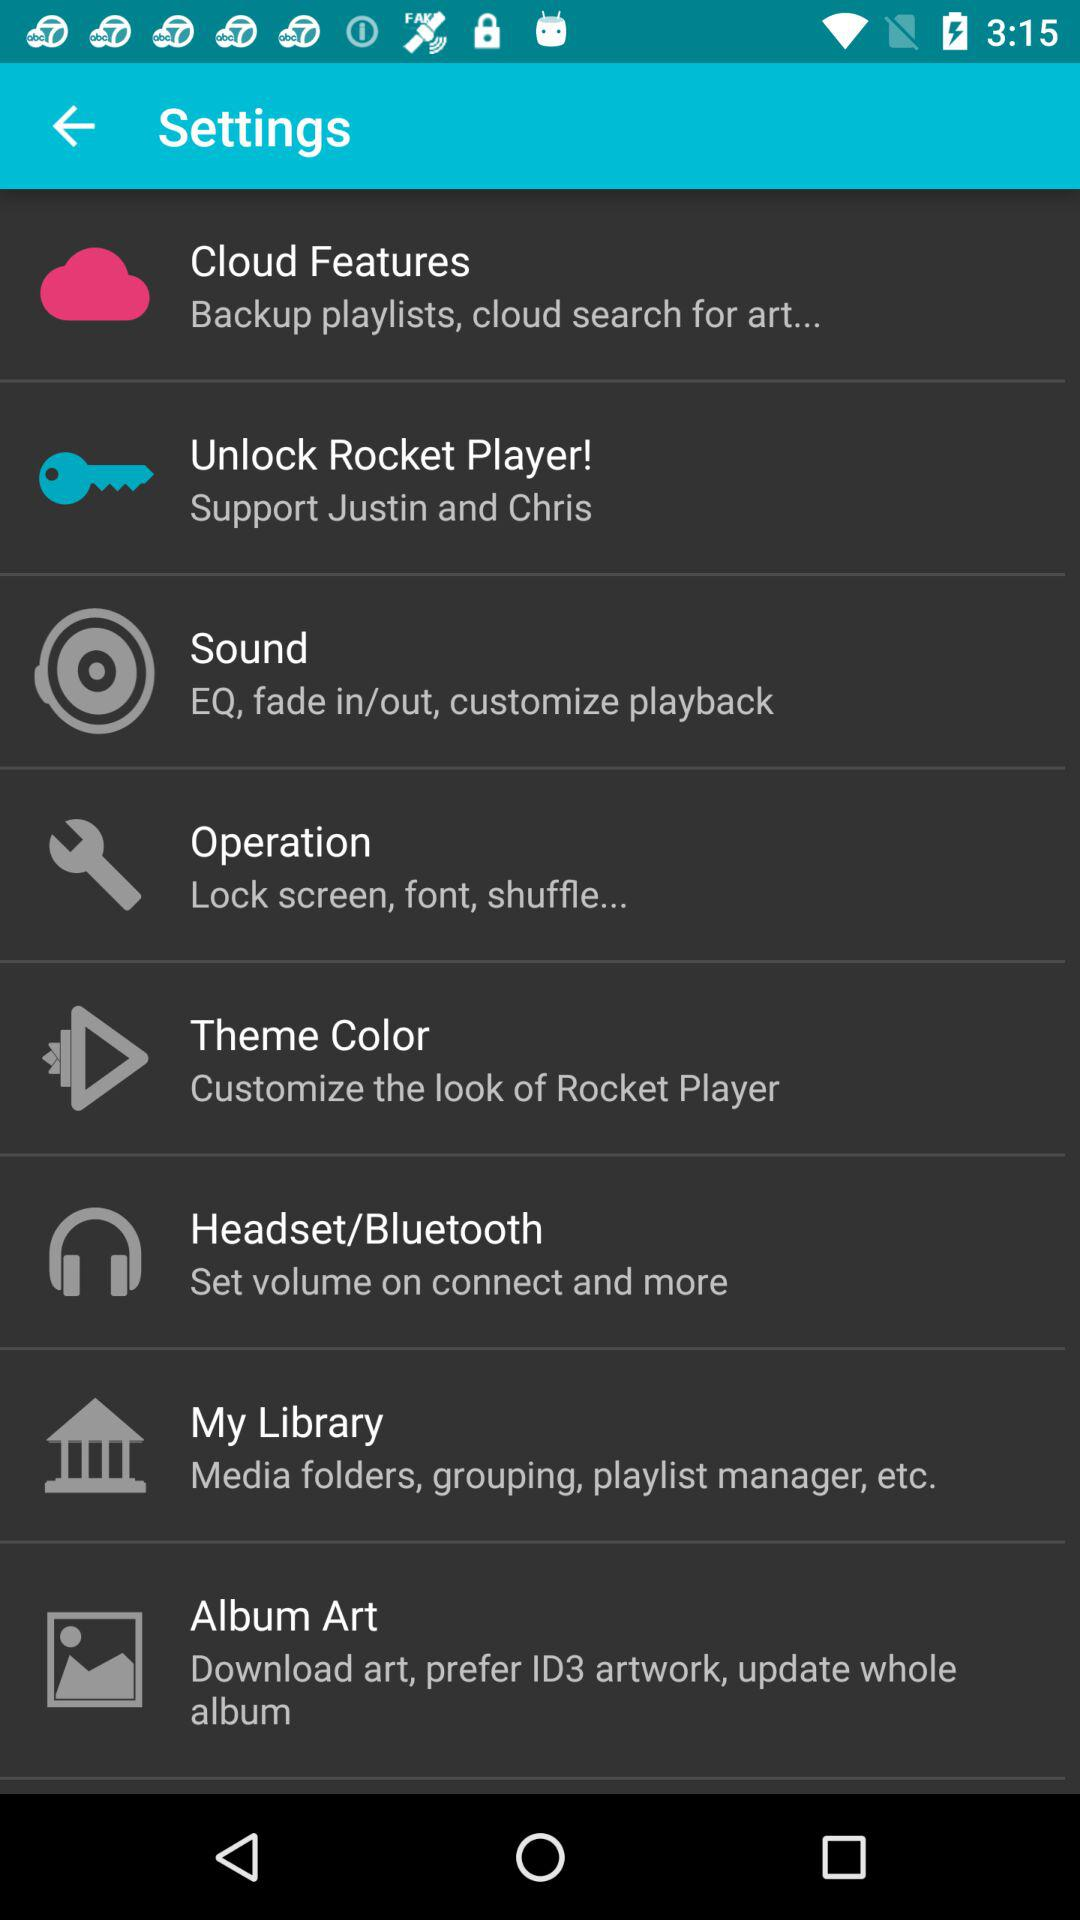How many items are in the Settings menu?
Answer the question using a single word or phrase. 8 